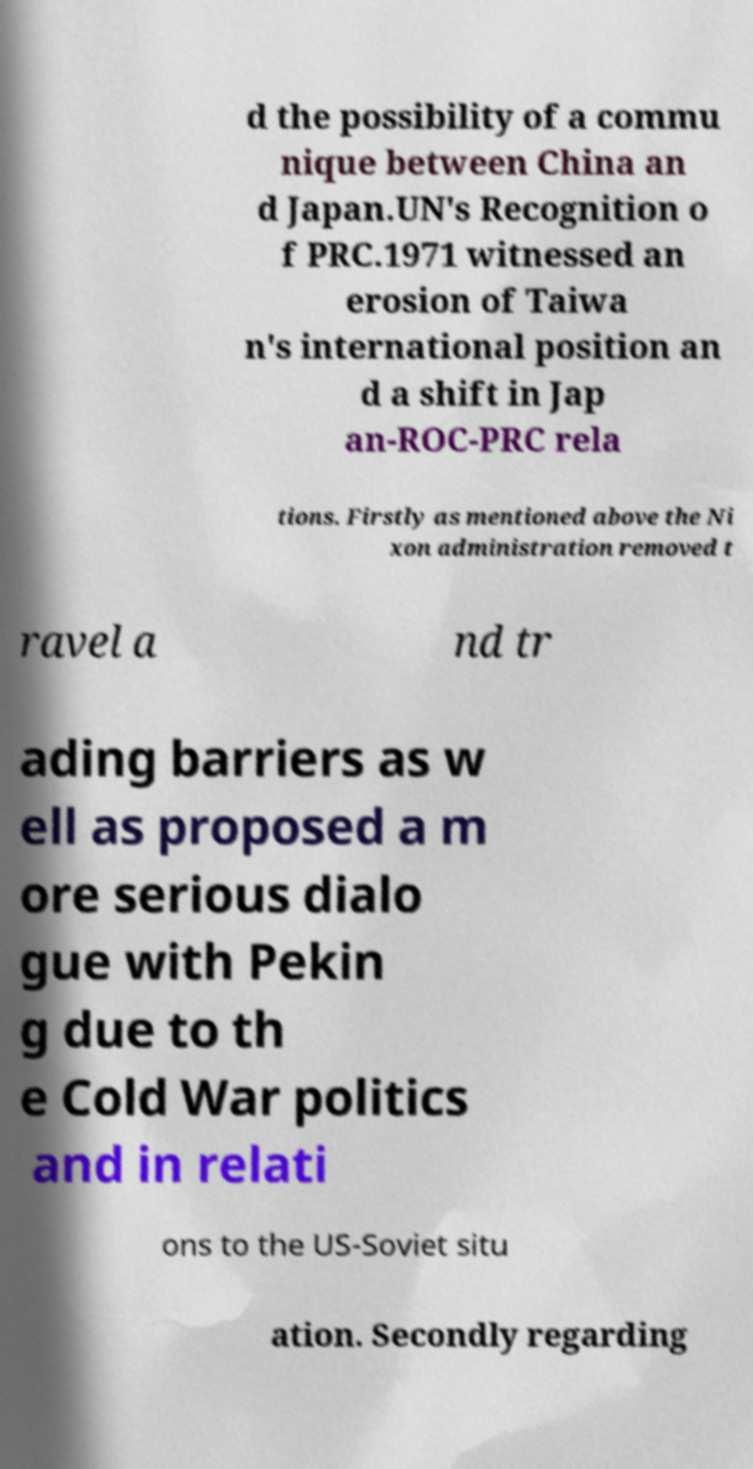What messages or text are displayed in this image? I need them in a readable, typed format. d the possibility of a commu nique between China an d Japan.UN's Recognition o f PRC.1971 witnessed an erosion of Taiwa n's international position an d a shift in Jap an-ROC-PRC rela tions. Firstly as mentioned above the Ni xon administration removed t ravel a nd tr ading barriers as w ell as proposed a m ore serious dialo gue with Pekin g due to th e Cold War politics and in relati ons to the US-Soviet situ ation. Secondly regarding 